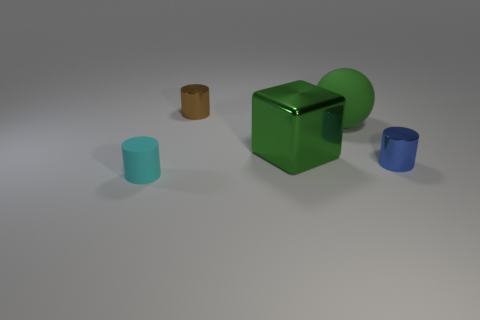Subtract all tiny matte cylinders. How many cylinders are left? 2 Subtract 1 cylinders. How many cylinders are left? 2 Subtract all brown cylinders. How many cylinders are left? 2 Subtract all balls. How many objects are left? 4 Add 3 cyan matte cylinders. How many cyan matte cylinders exist? 4 Add 1 small objects. How many objects exist? 6 Subtract 0 gray blocks. How many objects are left? 5 Subtract all green cylinders. Subtract all green spheres. How many cylinders are left? 3 Subtract all blue blocks. How many cyan cylinders are left? 1 Subtract all gray cylinders. Subtract all big cubes. How many objects are left? 4 